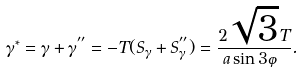<formula> <loc_0><loc_0><loc_500><loc_500>\gamma ^ { * } = \gamma + \gamma ^ { ^ { \prime \prime } } = - T ( S _ { \gamma } + S _ { \gamma } ^ { ^ { \prime \prime } } ) = \frac { 2 \sqrt { 3 } T } { a \sin 3 \varphi } .</formula> 